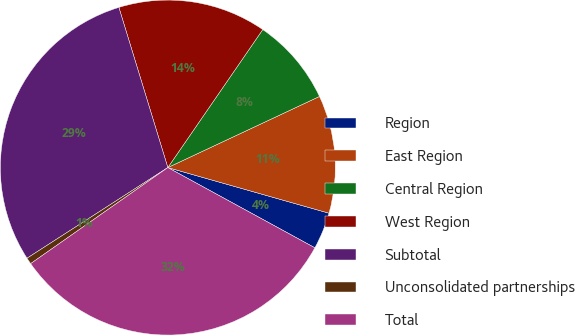<chart> <loc_0><loc_0><loc_500><loc_500><pie_chart><fcel>Region<fcel>East Region<fcel>Central Region<fcel>West Region<fcel>Subtotal<fcel>Unconsolidated partnerships<fcel>Total<nl><fcel>3.56%<fcel>11.37%<fcel>8.43%<fcel>14.31%<fcel>29.38%<fcel>0.62%<fcel>32.32%<nl></chart> 